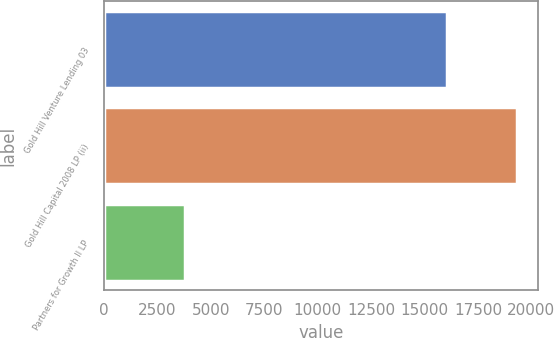<chart> <loc_0><loc_0><loc_500><loc_500><bar_chart><fcel>Gold Hill Venture Lending 03<fcel>Gold Hill Capital 2008 LP (ii)<fcel>Partners for Growth II LP<nl><fcel>16072<fcel>19328<fcel>3785<nl></chart> 